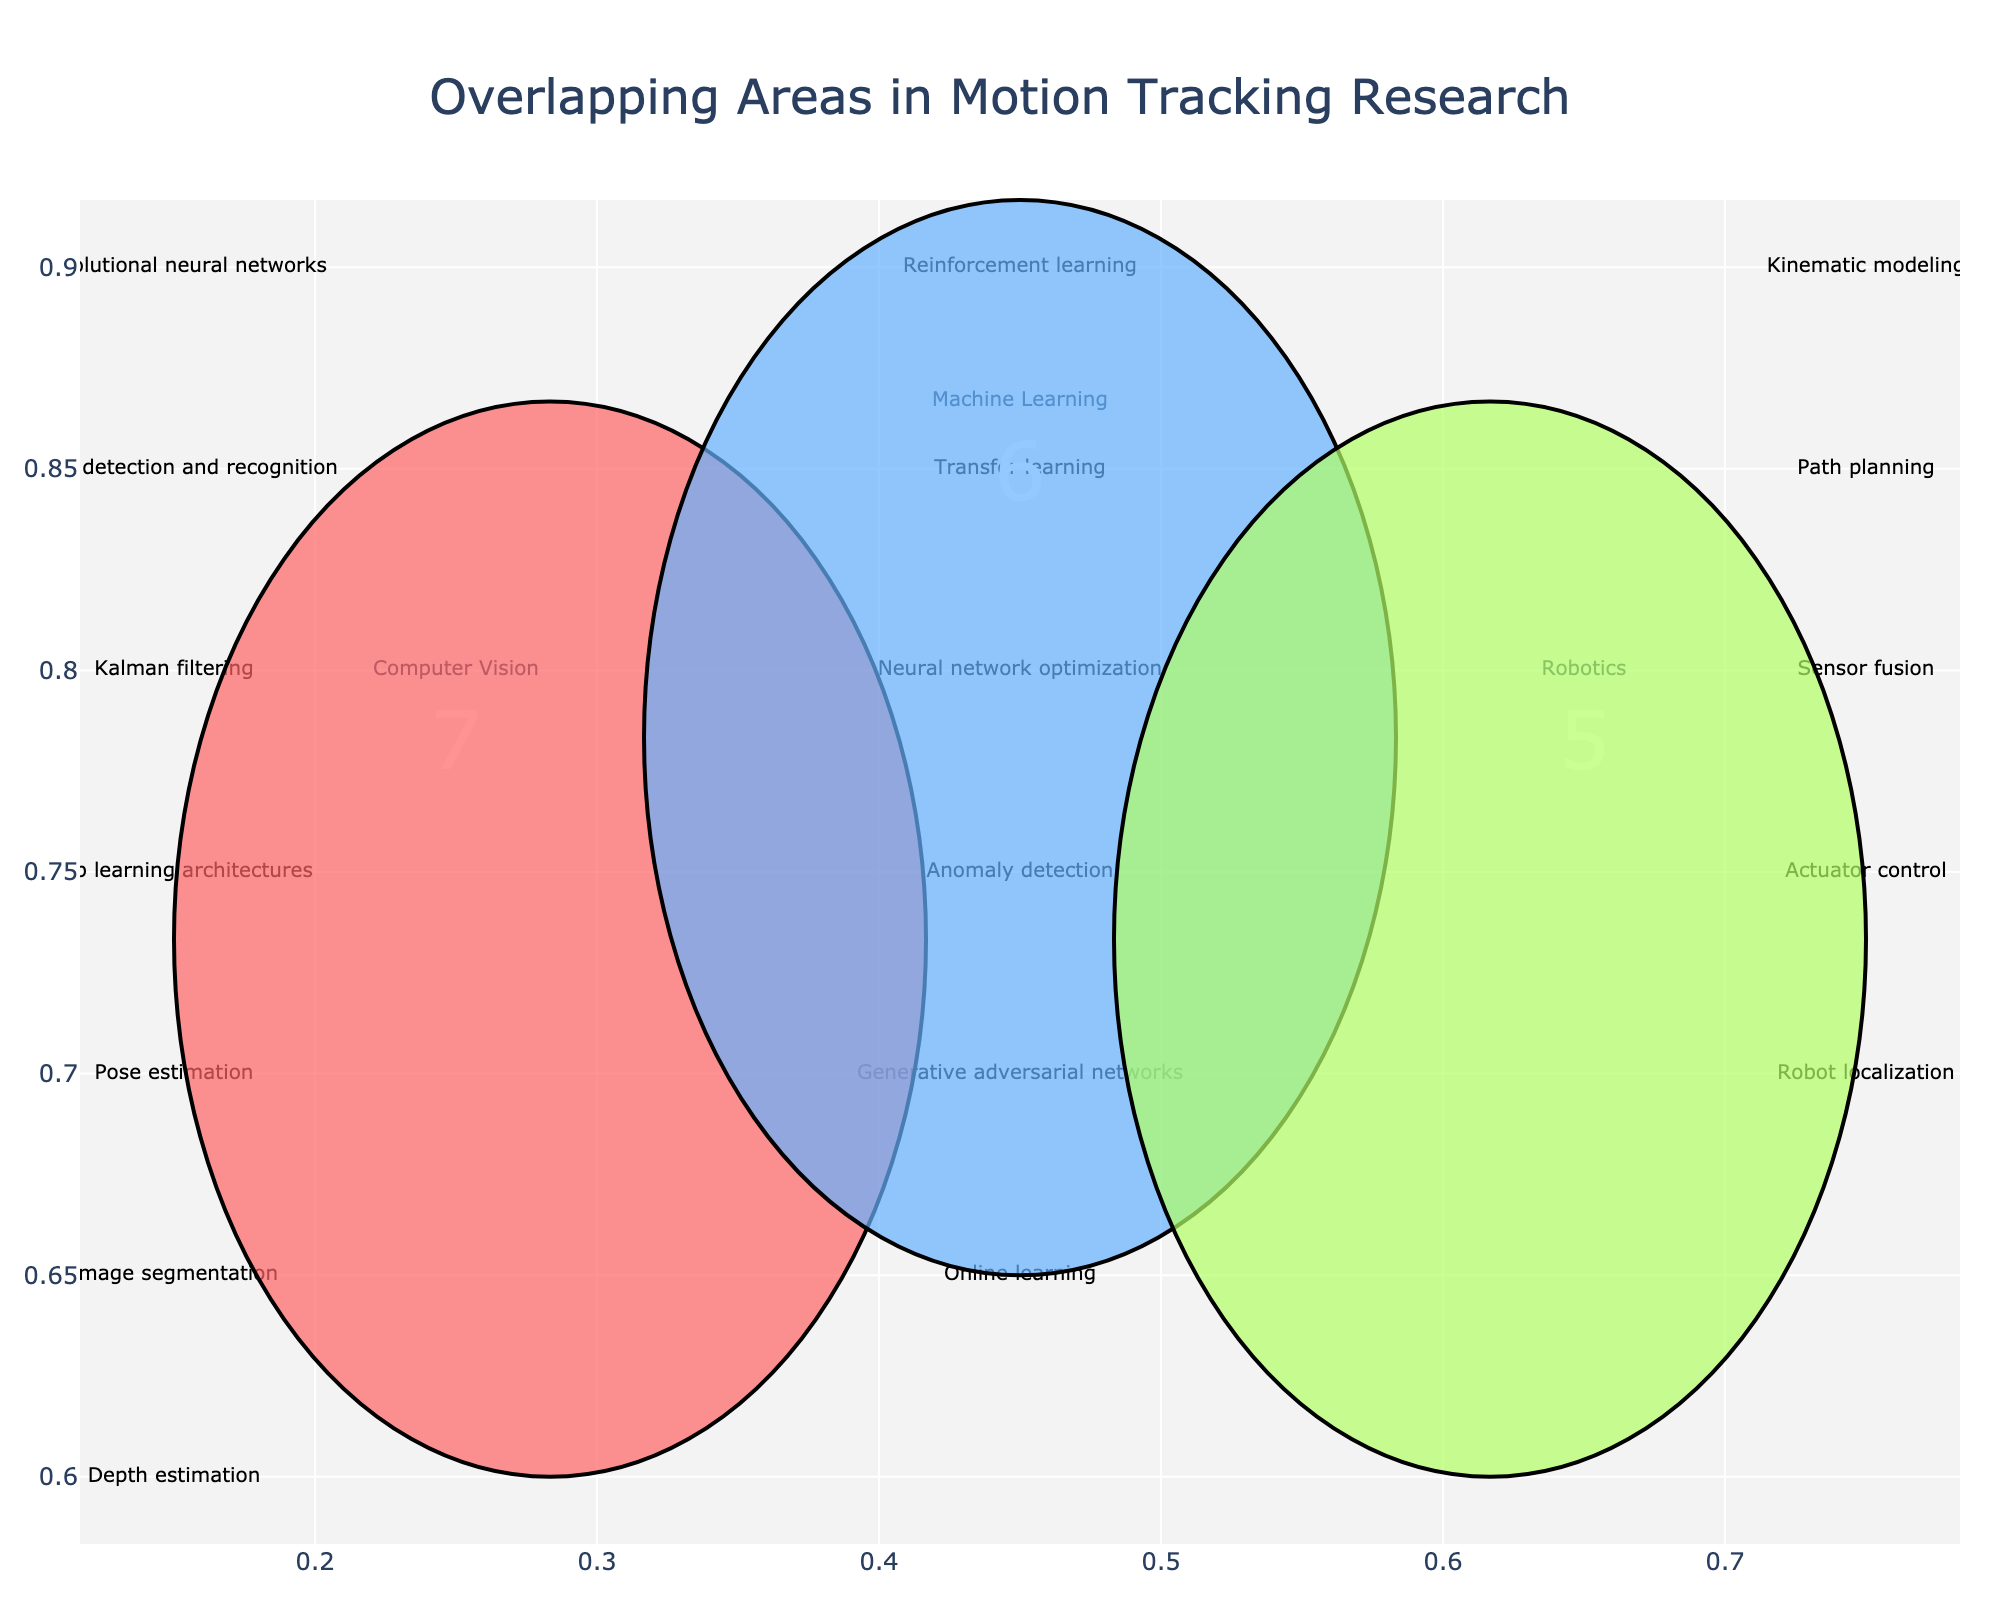Which area is associated with kinematic modeling? Kinematic modeling is listed under Robotics, so it falls within the Robotics area of the Venn diagram.
Answer: Robotics How many topics are associated exclusively with Computer Vision? Count the topics listed only under Computer Vision: Convolutional neural networks, Object detection and recognition, Kalman filtering, Pose estimation, Image segmentation, Depth estimation. There are 6 topics.
Answer: 6 Which topics are shared between Machine Learning and Robotics? There are no topics shared between Machine Learning and Robotics, as indicated by the absence of items that overlap between these two areas in the Venn diagram.
Answer: None What is the total number of topics across all three areas? Add the number of topics in each area: Computer Vision (6), Machine Learning (6), Robotics (7). The total is 6 + 6 + 7 = 19.
Answer: 19 Which area has the most number of topics? Compare the number of topics in each area: Computer Vision (6), Machine Learning (6), Robotics (7). Robotics has the most.
Answer: Robotics What are the unique features of Machine Learning related to motion tracking? The unique features of Machine Learning related to motion tracking include Reinforcement learning, Transfer learning, Neural network optimization, Anomaly detection, Generative adversarial networks, Online learning.
Answer: Reinforcement learning, Transfer learning, Neural network optimization, Anomaly detection, Generative adversarial networks, Online learning Compare the number of topics in Computer Vision and Machine Learning. Which has more? Count the topics in each: Computer Vision (6), Machine Learning (6). They have an equal number of topics.
Answer: Equal Which area includes sensor fusion? Sensor fusion is listed under Robotics, indicating it's associated with Robotics.
Answer: Robotics What is the relationship between depth estimation and path planning? Depth estimation is related to Computer Vision, while path planning is related to Robotics. They do not overlap directly according to the Venn diagram.
Answer: No direct relationship Which area includes most overlapping topics with others? Computer Vision and Machine Learning both have no overlapping topics with others according to the Venn diagram, but Robotics contain items unique to it. Hence, none of them overlap.
Answer: None 